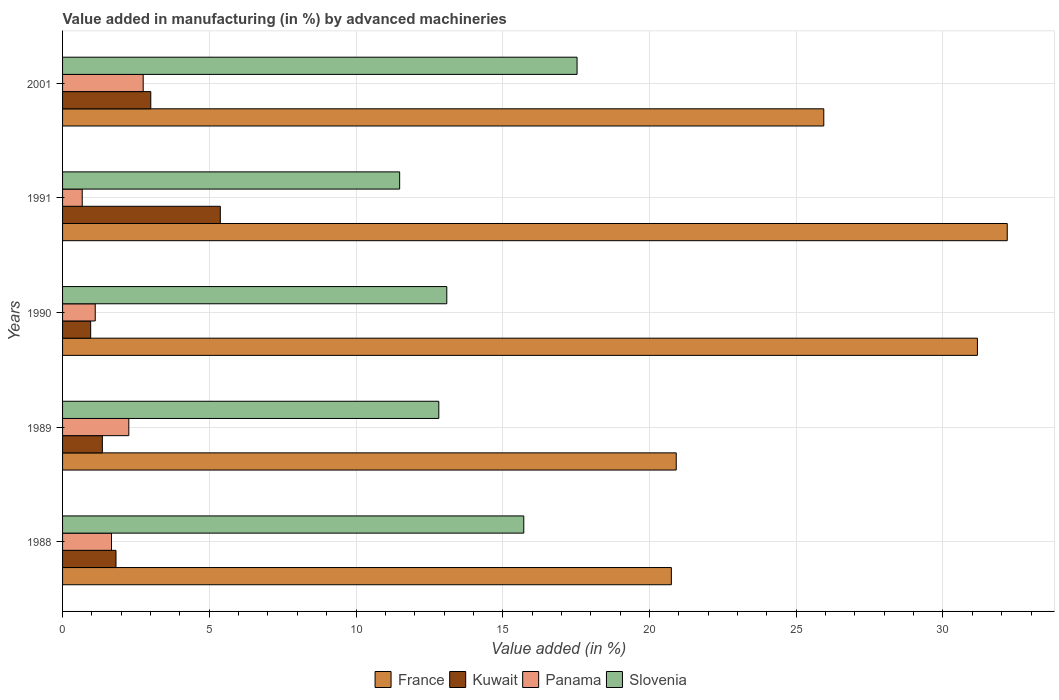How many different coloured bars are there?
Offer a terse response. 4. How many groups of bars are there?
Your answer should be very brief. 5. How many bars are there on the 5th tick from the bottom?
Keep it short and to the point. 4. What is the label of the 3rd group of bars from the top?
Provide a short and direct response. 1990. In how many cases, is the number of bars for a given year not equal to the number of legend labels?
Make the answer very short. 0. What is the percentage of value added in manufacturing by advanced machineries in France in 2001?
Your response must be concise. 25.94. Across all years, what is the maximum percentage of value added in manufacturing by advanced machineries in Kuwait?
Give a very brief answer. 5.38. Across all years, what is the minimum percentage of value added in manufacturing by advanced machineries in Kuwait?
Your answer should be very brief. 0.96. What is the total percentage of value added in manufacturing by advanced machineries in Kuwait in the graph?
Make the answer very short. 12.51. What is the difference between the percentage of value added in manufacturing by advanced machineries in Slovenia in 1989 and that in 1990?
Ensure brevity in your answer.  -0.27. What is the difference between the percentage of value added in manufacturing by advanced machineries in France in 1989 and the percentage of value added in manufacturing by advanced machineries in Panama in 2001?
Your answer should be compact. 18.16. What is the average percentage of value added in manufacturing by advanced machineries in Kuwait per year?
Make the answer very short. 2.5. In the year 1990, what is the difference between the percentage of value added in manufacturing by advanced machineries in France and percentage of value added in manufacturing by advanced machineries in Panama?
Give a very brief answer. 30.06. In how many years, is the percentage of value added in manufacturing by advanced machineries in France greater than 8 %?
Your answer should be compact. 5. What is the ratio of the percentage of value added in manufacturing by advanced machineries in Kuwait in 1988 to that in 1991?
Your response must be concise. 0.34. What is the difference between the highest and the second highest percentage of value added in manufacturing by advanced machineries in France?
Ensure brevity in your answer.  1.02. What is the difference between the highest and the lowest percentage of value added in manufacturing by advanced machineries in Slovenia?
Your response must be concise. 6.05. In how many years, is the percentage of value added in manufacturing by advanced machineries in Slovenia greater than the average percentage of value added in manufacturing by advanced machineries in Slovenia taken over all years?
Provide a short and direct response. 2. Is the sum of the percentage of value added in manufacturing by advanced machineries in France in 1988 and 1989 greater than the maximum percentage of value added in manufacturing by advanced machineries in Panama across all years?
Make the answer very short. Yes. What does the 2nd bar from the top in 2001 represents?
Your response must be concise. Panama. What does the 4th bar from the bottom in 1991 represents?
Make the answer very short. Slovenia. Is it the case that in every year, the sum of the percentage of value added in manufacturing by advanced machineries in France and percentage of value added in manufacturing by advanced machineries in Kuwait is greater than the percentage of value added in manufacturing by advanced machineries in Panama?
Provide a short and direct response. Yes. How many bars are there?
Give a very brief answer. 20. How many years are there in the graph?
Provide a succinct answer. 5. Are the values on the major ticks of X-axis written in scientific E-notation?
Offer a very short reply. No. Does the graph contain grids?
Give a very brief answer. Yes. Where does the legend appear in the graph?
Provide a short and direct response. Bottom center. How many legend labels are there?
Provide a succinct answer. 4. What is the title of the graph?
Give a very brief answer. Value added in manufacturing (in %) by advanced machineries. What is the label or title of the X-axis?
Your answer should be compact. Value added (in %). What is the Value added (in %) in France in 1988?
Your answer should be very brief. 20.75. What is the Value added (in %) in Kuwait in 1988?
Ensure brevity in your answer.  1.82. What is the Value added (in %) of Panama in 1988?
Keep it short and to the point. 1.67. What is the Value added (in %) in Slovenia in 1988?
Provide a succinct answer. 15.72. What is the Value added (in %) in France in 1989?
Give a very brief answer. 20.91. What is the Value added (in %) in Kuwait in 1989?
Give a very brief answer. 1.36. What is the Value added (in %) in Panama in 1989?
Give a very brief answer. 2.26. What is the Value added (in %) of Slovenia in 1989?
Ensure brevity in your answer.  12.82. What is the Value added (in %) of France in 1990?
Your answer should be very brief. 31.17. What is the Value added (in %) of Kuwait in 1990?
Provide a short and direct response. 0.96. What is the Value added (in %) in Panama in 1990?
Your answer should be very brief. 1.11. What is the Value added (in %) of Slovenia in 1990?
Ensure brevity in your answer.  13.09. What is the Value added (in %) in France in 1991?
Provide a succinct answer. 32.19. What is the Value added (in %) of Kuwait in 1991?
Provide a short and direct response. 5.38. What is the Value added (in %) of Panama in 1991?
Provide a succinct answer. 0.67. What is the Value added (in %) of Slovenia in 1991?
Give a very brief answer. 11.49. What is the Value added (in %) of France in 2001?
Your response must be concise. 25.94. What is the Value added (in %) of Kuwait in 2001?
Provide a short and direct response. 3.01. What is the Value added (in %) of Panama in 2001?
Provide a succinct answer. 2.75. What is the Value added (in %) in Slovenia in 2001?
Offer a very short reply. 17.53. Across all years, what is the maximum Value added (in %) of France?
Provide a succinct answer. 32.19. Across all years, what is the maximum Value added (in %) in Kuwait?
Offer a very short reply. 5.38. Across all years, what is the maximum Value added (in %) of Panama?
Offer a terse response. 2.75. Across all years, what is the maximum Value added (in %) in Slovenia?
Make the answer very short. 17.53. Across all years, what is the minimum Value added (in %) of France?
Offer a very short reply. 20.75. Across all years, what is the minimum Value added (in %) in Kuwait?
Provide a short and direct response. 0.96. Across all years, what is the minimum Value added (in %) in Panama?
Make the answer very short. 0.67. Across all years, what is the minimum Value added (in %) in Slovenia?
Give a very brief answer. 11.49. What is the total Value added (in %) of France in the graph?
Offer a very short reply. 130.96. What is the total Value added (in %) in Kuwait in the graph?
Your answer should be very brief. 12.51. What is the total Value added (in %) in Panama in the graph?
Ensure brevity in your answer.  8.46. What is the total Value added (in %) of Slovenia in the graph?
Provide a short and direct response. 70.65. What is the difference between the Value added (in %) of France in 1988 and that in 1989?
Your response must be concise. -0.17. What is the difference between the Value added (in %) in Kuwait in 1988 and that in 1989?
Your answer should be very brief. 0.46. What is the difference between the Value added (in %) in Panama in 1988 and that in 1989?
Make the answer very short. -0.59. What is the difference between the Value added (in %) in Slovenia in 1988 and that in 1989?
Give a very brief answer. 2.9. What is the difference between the Value added (in %) in France in 1988 and that in 1990?
Keep it short and to the point. -10.43. What is the difference between the Value added (in %) of Kuwait in 1988 and that in 1990?
Offer a terse response. 0.86. What is the difference between the Value added (in %) of Panama in 1988 and that in 1990?
Offer a terse response. 0.55. What is the difference between the Value added (in %) in Slovenia in 1988 and that in 1990?
Your answer should be compact. 2.62. What is the difference between the Value added (in %) in France in 1988 and that in 1991?
Offer a very short reply. -11.45. What is the difference between the Value added (in %) in Kuwait in 1988 and that in 1991?
Make the answer very short. -3.55. What is the difference between the Value added (in %) in Slovenia in 1988 and that in 1991?
Offer a very short reply. 4.23. What is the difference between the Value added (in %) of France in 1988 and that in 2001?
Ensure brevity in your answer.  -5.19. What is the difference between the Value added (in %) in Kuwait in 1988 and that in 2001?
Ensure brevity in your answer.  -1.19. What is the difference between the Value added (in %) of Panama in 1988 and that in 2001?
Offer a terse response. -1.08. What is the difference between the Value added (in %) in Slovenia in 1988 and that in 2001?
Keep it short and to the point. -1.82. What is the difference between the Value added (in %) of France in 1989 and that in 1990?
Ensure brevity in your answer.  -10.26. What is the difference between the Value added (in %) in Kuwait in 1989 and that in 1990?
Your answer should be compact. 0.4. What is the difference between the Value added (in %) in Panama in 1989 and that in 1990?
Offer a very short reply. 1.14. What is the difference between the Value added (in %) of Slovenia in 1989 and that in 1990?
Your answer should be compact. -0.27. What is the difference between the Value added (in %) of France in 1989 and that in 1991?
Give a very brief answer. -11.28. What is the difference between the Value added (in %) in Kuwait in 1989 and that in 1991?
Your answer should be compact. -4.02. What is the difference between the Value added (in %) in Panama in 1989 and that in 1991?
Offer a terse response. 1.59. What is the difference between the Value added (in %) of Slovenia in 1989 and that in 1991?
Offer a very short reply. 1.33. What is the difference between the Value added (in %) of France in 1989 and that in 2001?
Your answer should be very brief. -5.03. What is the difference between the Value added (in %) of Kuwait in 1989 and that in 2001?
Ensure brevity in your answer.  -1.65. What is the difference between the Value added (in %) of Panama in 1989 and that in 2001?
Offer a terse response. -0.49. What is the difference between the Value added (in %) in Slovenia in 1989 and that in 2001?
Keep it short and to the point. -4.71. What is the difference between the Value added (in %) in France in 1990 and that in 1991?
Offer a terse response. -1.02. What is the difference between the Value added (in %) in Kuwait in 1990 and that in 1991?
Ensure brevity in your answer.  -4.42. What is the difference between the Value added (in %) in Panama in 1990 and that in 1991?
Make the answer very short. 0.44. What is the difference between the Value added (in %) in Slovenia in 1990 and that in 1991?
Ensure brevity in your answer.  1.61. What is the difference between the Value added (in %) in France in 1990 and that in 2001?
Offer a terse response. 5.24. What is the difference between the Value added (in %) of Kuwait in 1990 and that in 2001?
Ensure brevity in your answer.  -2.05. What is the difference between the Value added (in %) in Panama in 1990 and that in 2001?
Provide a succinct answer. -1.63. What is the difference between the Value added (in %) of Slovenia in 1990 and that in 2001?
Ensure brevity in your answer.  -4.44. What is the difference between the Value added (in %) of France in 1991 and that in 2001?
Your response must be concise. 6.25. What is the difference between the Value added (in %) in Kuwait in 1991 and that in 2001?
Make the answer very short. 2.37. What is the difference between the Value added (in %) of Panama in 1991 and that in 2001?
Ensure brevity in your answer.  -2.08. What is the difference between the Value added (in %) of Slovenia in 1991 and that in 2001?
Give a very brief answer. -6.04. What is the difference between the Value added (in %) in France in 1988 and the Value added (in %) in Kuwait in 1989?
Offer a very short reply. 19.39. What is the difference between the Value added (in %) of France in 1988 and the Value added (in %) of Panama in 1989?
Ensure brevity in your answer.  18.49. What is the difference between the Value added (in %) in France in 1988 and the Value added (in %) in Slovenia in 1989?
Your answer should be very brief. 7.92. What is the difference between the Value added (in %) of Kuwait in 1988 and the Value added (in %) of Panama in 1989?
Make the answer very short. -0.44. What is the difference between the Value added (in %) of Kuwait in 1988 and the Value added (in %) of Slovenia in 1989?
Your answer should be very brief. -11. What is the difference between the Value added (in %) in Panama in 1988 and the Value added (in %) in Slovenia in 1989?
Ensure brevity in your answer.  -11.15. What is the difference between the Value added (in %) of France in 1988 and the Value added (in %) of Kuwait in 1990?
Make the answer very short. 19.79. What is the difference between the Value added (in %) in France in 1988 and the Value added (in %) in Panama in 1990?
Your response must be concise. 19.63. What is the difference between the Value added (in %) in France in 1988 and the Value added (in %) in Slovenia in 1990?
Your answer should be compact. 7.65. What is the difference between the Value added (in %) in Kuwait in 1988 and the Value added (in %) in Panama in 1990?
Provide a succinct answer. 0.71. What is the difference between the Value added (in %) of Kuwait in 1988 and the Value added (in %) of Slovenia in 1990?
Your response must be concise. -11.27. What is the difference between the Value added (in %) in Panama in 1988 and the Value added (in %) in Slovenia in 1990?
Offer a terse response. -11.43. What is the difference between the Value added (in %) of France in 1988 and the Value added (in %) of Kuwait in 1991?
Offer a terse response. 15.37. What is the difference between the Value added (in %) of France in 1988 and the Value added (in %) of Panama in 1991?
Give a very brief answer. 20.08. What is the difference between the Value added (in %) of France in 1988 and the Value added (in %) of Slovenia in 1991?
Ensure brevity in your answer.  9.26. What is the difference between the Value added (in %) in Kuwait in 1988 and the Value added (in %) in Panama in 1991?
Keep it short and to the point. 1.15. What is the difference between the Value added (in %) of Kuwait in 1988 and the Value added (in %) of Slovenia in 1991?
Offer a terse response. -9.67. What is the difference between the Value added (in %) in Panama in 1988 and the Value added (in %) in Slovenia in 1991?
Provide a succinct answer. -9.82. What is the difference between the Value added (in %) of France in 1988 and the Value added (in %) of Kuwait in 2001?
Provide a short and direct response. 17.74. What is the difference between the Value added (in %) of France in 1988 and the Value added (in %) of Panama in 2001?
Give a very brief answer. 18. What is the difference between the Value added (in %) in France in 1988 and the Value added (in %) in Slovenia in 2001?
Your answer should be very brief. 3.21. What is the difference between the Value added (in %) of Kuwait in 1988 and the Value added (in %) of Panama in 2001?
Your answer should be very brief. -0.93. What is the difference between the Value added (in %) of Kuwait in 1988 and the Value added (in %) of Slovenia in 2001?
Provide a succinct answer. -15.71. What is the difference between the Value added (in %) of Panama in 1988 and the Value added (in %) of Slovenia in 2001?
Your answer should be compact. -15.86. What is the difference between the Value added (in %) of France in 1989 and the Value added (in %) of Kuwait in 1990?
Keep it short and to the point. 19.95. What is the difference between the Value added (in %) of France in 1989 and the Value added (in %) of Panama in 1990?
Give a very brief answer. 19.8. What is the difference between the Value added (in %) of France in 1989 and the Value added (in %) of Slovenia in 1990?
Offer a terse response. 7.82. What is the difference between the Value added (in %) of Kuwait in 1989 and the Value added (in %) of Panama in 1990?
Your response must be concise. 0.24. What is the difference between the Value added (in %) of Kuwait in 1989 and the Value added (in %) of Slovenia in 1990?
Offer a very short reply. -11.74. What is the difference between the Value added (in %) of Panama in 1989 and the Value added (in %) of Slovenia in 1990?
Provide a short and direct response. -10.84. What is the difference between the Value added (in %) in France in 1989 and the Value added (in %) in Kuwait in 1991?
Offer a very short reply. 15.54. What is the difference between the Value added (in %) in France in 1989 and the Value added (in %) in Panama in 1991?
Provide a short and direct response. 20.24. What is the difference between the Value added (in %) in France in 1989 and the Value added (in %) in Slovenia in 1991?
Provide a succinct answer. 9.42. What is the difference between the Value added (in %) of Kuwait in 1989 and the Value added (in %) of Panama in 1991?
Ensure brevity in your answer.  0.69. What is the difference between the Value added (in %) in Kuwait in 1989 and the Value added (in %) in Slovenia in 1991?
Offer a very short reply. -10.13. What is the difference between the Value added (in %) of Panama in 1989 and the Value added (in %) of Slovenia in 1991?
Provide a succinct answer. -9.23. What is the difference between the Value added (in %) of France in 1989 and the Value added (in %) of Kuwait in 2001?
Your answer should be compact. 17.91. What is the difference between the Value added (in %) of France in 1989 and the Value added (in %) of Panama in 2001?
Your answer should be compact. 18.16. What is the difference between the Value added (in %) of France in 1989 and the Value added (in %) of Slovenia in 2001?
Your response must be concise. 3.38. What is the difference between the Value added (in %) in Kuwait in 1989 and the Value added (in %) in Panama in 2001?
Provide a succinct answer. -1.39. What is the difference between the Value added (in %) of Kuwait in 1989 and the Value added (in %) of Slovenia in 2001?
Offer a very short reply. -16.18. What is the difference between the Value added (in %) in Panama in 1989 and the Value added (in %) in Slovenia in 2001?
Provide a short and direct response. -15.27. What is the difference between the Value added (in %) of France in 1990 and the Value added (in %) of Kuwait in 1991?
Your answer should be compact. 25.8. What is the difference between the Value added (in %) of France in 1990 and the Value added (in %) of Panama in 1991?
Give a very brief answer. 30.5. What is the difference between the Value added (in %) in France in 1990 and the Value added (in %) in Slovenia in 1991?
Offer a terse response. 19.69. What is the difference between the Value added (in %) of Kuwait in 1990 and the Value added (in %) of Panama in 1991?
Provide a short and direct response. 0.29. What is the difference between the Value added (in %) of Kuwait in 1990 and the Value added (in %) of Slovenia in 1991?
Offer a very short reply. -10.53. What is the difference between the Value added (in %) of Panama in 1990 and the Value added (in %) of Slovenia in 1991?
Keep it short and to the point. -10.37. What is the difference between the Value added (in %) in France in 1990 and the Value added (in %) in Kuwait in 2001?
Keep it short and to the point. 28.17. What is the difference between the Value added (in %) of France in 1990 and the Value added (in %) of Panama in 2001?
Provide a succinct answer. 28.43. What is the difference between the Value added (in %) in France in 1990 and the Value added (in %) in Slovenia in 2001?
Offer a terse response. 13.64. What is the difference between the Value added (in %) of Kuwait in 1990 and the Value added (in %) of Panama in 2001?
Provide a succinct answer. -1.79. What is the difference between the Value added (in %) in Kuwait in 1990 and the Value added (in %) in Slovenia in 2001?
Provide a short and direct response. -16.57. What is the difference between the Value added (in %) of Panama in 1990 and the Value added (in %) of Slovenia in 2001?
Offer a terse response. -16.42. What is the difference between the Value added (in %) of France in 1991 and the Value added (in %) of Kuwait in 2001?
Keep it short and to the point. 29.19. What is the difference between the Value added (in %) of France in 1991 and the Value added (in %) of Panama in 2001?
Your answer should be very brief. 29.44. What is the difference between the Value added (in %) in France in 1991 and the Value added (in %) in Slovenia in 2001?
Make the answer very short. 14.66. What is the difference between the Value added (in %) in Kuwait in 1991 and the Value added (in %) in Panama in 2001?
Your answer should be very brief. 2.63. What is the difference between the Value added (in %) in Kuwait in 1991 and the Value added (in %) in Slovenia in 2001?
Provide a succinct answer. -12.16. What is the difference between the Value added (in %) of Panama in 1991 and the Value added (in %) of Slovenia in 2001?
Provide a short and direct response. -16.86. What is the average Value added (in %) of France per year?
Your answer should be very brief. 26.19. What is the average Value added (in %) in Kuwait per year?
Provide a short and direct response. 2.5. What is the average Value added (in %) in Panama per year?
Make the answer very short. 1.69. What is the average Value added (in %) in Slovenia per year?
Offer a terse response. 14.13. In the year 1988, what is the difference between the Value added (in %) in France and Value added (in %) in Kuwait?
Offer a terse response. 18.92. In the year 1988, what is the difference between the Value added (in %) in France and Value added (in %) in Panama?
Make the answer very short. 19.08. In the year 1988, what is the difference between the Value added (in %) in France and Value added (in %) in Slovenia?
Your response must be concise. 5.03. In the year 1988, what is the difference between the Value added (in %) in Kuwait and Value added (in %) in Panama?
Keep it short and to the point. 0.15. In the year 1988, what is the difference between the Value added (in %) in Kuwait and Value added (in %) in Slovenia?
Offer a terse response. -13.9. In the year 1988, what is the difference between the Value added (in %) in Panama and Value added (in %) in Slovenia?
Offer a very short reply. -14.05. In the year 1989, what is the difference between the Value added (in %) in France and Value added (in %) in Kuwait?
Your answer should be very brief. 19.56. In the year 1989, what is the difference between the Value added (in %) of France and Value added (in %) of Panama?
Your answer should be compact. 18.65. In the year 1989, what is the difference between the Value added (in %) in France and Value added (in %) in Slovenia?
Your answer should be compact. 8.09. In the year 1989, what is the difference between the Value added (in %) of Kuwait and Value added (in %) of Panama?
Offer a very short reply. -0.9. In the year 1989, what is the difference between the Value added (in %) in Kuwait and Value added (in %) in Slovenia?
Provide a short and direct response. -11.46. In the year 1989, what is the difference between the Value added (in %) in Panama and Value added (in %) in Slovenia?
Your response must be concise. -10.56. In the year 1990, what is the difference between the Value added (in %) of France and Value added (in %) of Kuwait?
Your response must be concise. 30.22. In the year 1990, what is the difference between the Value added (in %) of France and Value added (in %) of Panama?
Provide a short and direct response. 30.06. In the year 1990, what is the difference between the Value added (in %) of France and Value added (in %) of Slovenia?
Your answer should be compact. 18.08. In the year 1990, what is the difference between the Value added (in %) of Kuwait and Value added (in %) of Panama?
Offer a very short reply. -0.16. In the year 1990, what is the difference between the Value added (in %) of Kuwait and Value added (in %) of Slovenia?
Give a very brief answer. -12.14. In the year 1990, what is the difference between the Value added (in %) of Panama and Value added (in %) of Slovenia?
Your answer should be compact. -11.98. In the year 1991, what is the difference between the Value added (in %) of France and Value added (in %) of Kuwait?
Keep it short and to the point. 26.82. In the year 1991, what is the difference between the Value added (in %) in France and Value added (in %) in Panama?
Keep it short and to the point. 31.52. In the year 1991, what is the difference between the Value added (in %) in France and Value added (in %) in Slovenia?
Make the answer very short. 20.7. In the year 1991, what is the difference between the Value added (in %) in Kuwait and Value added (in %) in Panama?
Offer a terse response. 4.7. In the year 1991, what is the difference between the Value added (in %) in Kuwait and Value added (in %) in Slovenia?
Provide a succinct answer. -6.11. In the year 1991, what is the difference between the Value added (in %) in Panama and Value added (in %) in Slovenia?
Make the answer very short. -10.82. In the year 2001, what is the difference between the Value added (in %) of France and Value added (in %) of Kuwait?
Give a very brief answer. 22.93. In the year 2001, what is the difference between the Value added (in %) of France and Value added (in %) of Panama?
Your response must be concise. 23.19. In the year 2001, what is the difference between the Value added (in %) of France and Value added (in %) of Slovenia?
Keep it short and to the point. 8.41. In the year 2001, what is the difference between the Value added (in %) in Kuwait and Value added (in %) in Panama?
Your answer should be very brief. 0.26. In the year 2001, what is the difference between the Value added (in %) of Kuwait and Value added (in %) of Slovenia?
Your answer should be very brief. -14.53. In the year 2001, what is the difference between the Value added (in %) of Panama and Value added (in %) of Slovenia?
Your response must be concise. -14.78. What is the ratio of the Value added (in %) in France in 1988 to that in 1989?
Ensure brevity in your answer.  0.99. What is the ratio of the Value added (in %) in Kuwait in 1988 to that in 1989?
Make the answer very short. 1.34. What is the ratio of the Value added (in %) in Panama in 1988 to that in 1989?
Offer a terse response. 0.74. What is the ratio of the Value added (in %) in Slovenia in 1988 to that in 1989?
Provide a short and direct response. 1.23. What is the ratio of the Value added (in %) of France in 1988 to that in 1990?
Provide a succinct answer. 0.67. What is the ratio of the Value added (in %) in Kuwait in 1988 to that in 1990?
Your response must be concise. 1.9. What is the ratio of the Value added (in %) in Panama in 1988 to that in 1990?
Provide a short and direct response. 1.5. What is the ratio of the Value added (in %) of Slovenia in 1988 to that in 1990?
Give a very brief answer. 1.2. What is the ratio of the Value added (in %) of France in 1988 to that in 1991?
Make the answer very short. 0.64. What is the ratio of the Value added (in %) of Kuwait in 1988 to that in 1991?
Make the answer very short. 0.34. What is the ratio of the Value added (in %) of Panama in 1988 to that in 1991?
Provide a short and direct response. 2.49. What is the ratio of the Value added (in %) in Slovenia in 1988 to that in 1991?
Provide a short and direct response. 1.37. What is the ratio of the Value added (in %) in France in 1988 to that in 2001?
Make the answer very short. 0.8. What is the ratio of the Value added (in %) in Kuwait in 1988 to that in 2001?
Ensure brevity in your answer.  0.61. What is the ratio of the Value added (in %) in Panama in 1988 to that in 2001?
Give a very brief answer. 0.61. What is the ratio of the Value added (in %) in Slovenia in 1988 to that in 2001?
Your answer should be compact. 0.9. What is the ratio of the Value added (in %) in France in 1989 to that in 1990?
Provide a succinct answer. 0.67. What is the ratio of the Value added (in %) of Kuwait in 1989 to that in 1990?
Provide a succinct answer. 1.42. What is the ratio of the Value added (in %) of Panama in 1989 to that in 1990?
Offer a very short reply. 2.03. What is the ratio of the Value added (in %) in Slovenia in 1989 to that in 1990?
Offer a terse response. 0.98. What is the ratio of the Value added (in %) of France in 1989 to that in 1991?
Your answer should be compact. 0.65. What is the ratio of the Value added (in %) in Kuwait in 1989 to that in 1991?
Make the answer very short. 0.25. What is the ratio of the Value added (in %) of Panama in 1989 to that in 1991?
Provide a short and direct response. 3.37. What is the ratio of the Value added (in %) of Slovenia in 1989 to that in 1991?
Ensure brevity in your answer.  1.12. What is the ratio of the Value added (in %) of France in 1989 to that in 2001?
Provide a succinct answer. 0.81. What is the ratio of the Value added (in %) of Kuwait in 1989 to that in 2001?
Provide a short and direct response. 0.45. What is the ratio of the Value added (in %) in Panama in 1989 to that in 2001?
Keep it short and to the point. 0.82. What is the ratio of the Value added (in %) of Slovenia in 1989 to that in 2001?
Your answer should be compact. 0.73. What is the ratio of the Value added (in %) in France in 1990 to that in 1991?
Ensure brevity in your answer.  0.97. What is the ratio of the Value added (in %) in Kuwait in 1990 to that in 1991?
Your answer should be compact. 0.18. What is the ratio of the Value added (in %) of Panama in 1990 to that in 1991?
Make the answer very short. 1.66. What is the ratio of the Value added (in %) of Slovenia in 1990 to that in 1991?
Offer a very short reply. 1.14. What is the ratio of the Value added (in %) of France in 1990 to that in 2001?
Ensure brevity in your answer.  1.2. What is the ratio of the Value added (in %) in Kuwait in 1990 to that in 2001?
Your answer should be very brief. 0.32. What is the ratio of the Value added (in %) in Panama in 1990 to that in 2001?
Ensure brevity in your answer.  0.41. What is the ratio of the Value added (in %) in Slovenia in 1990 to that in 2001?
Offer a terse response. 0.75. What is the ratio of the Value added (in %) in France in 1991 to that in 2001?
Your answer should be compact. 1.24. What is the ratio of the Value added (in %) in Kuwait in 1991 to that in 2001?
Keep it short and to the point. 1.79. What is the ratio of the Value added (in %) of Panama in 1991 to that in 2001?
Give a very brief answer. 0.24. What is the ratio of the Value added (in %) of Slovenia in 1991 to that in 2001?
Your response must be concise. 0.66. What is the difference between the highest and the second highest Value added (in %) in France?
Provide a succinct answer. 1.02. What is the difference between the highest and the second highest Value added (in %) of Kuwait?
Your answer should be compact. 2.37. What is the difference between the highest and the second highest Value added (in %) in Panama?
Give a very brief answer. 0.49. What is the difference between the highest and the second highest Value added (in %) of Slovenia?
Provide a short and direct response. 1.82. What is the difference between the highest and the lowest Value added (in %) in France?
Your response must be concise. 11.45. What is the difference between the highest and the lowest Value added (in %) in Kuwait?
Ensure brevity in your answer.  4.42. What is the difference between the highest and the lowest Value added (in %) in Panama?
Your answer should be compact. 2.08. What is the difference between the highest and the lowest Value added (in %) of Slovenia?
Ensure brevity in your answer.  6.04. 